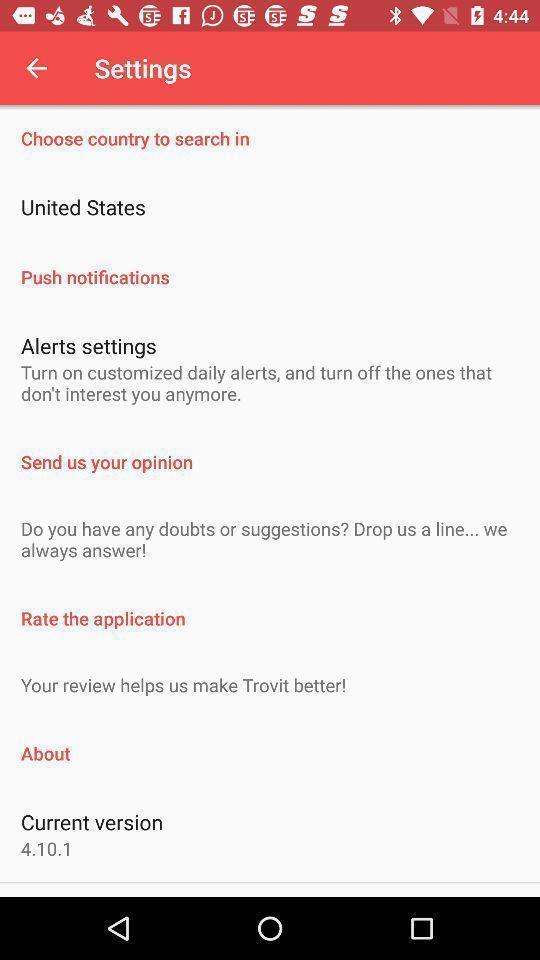Explain what's happening in this screen capture. Setting page displaying various options. 